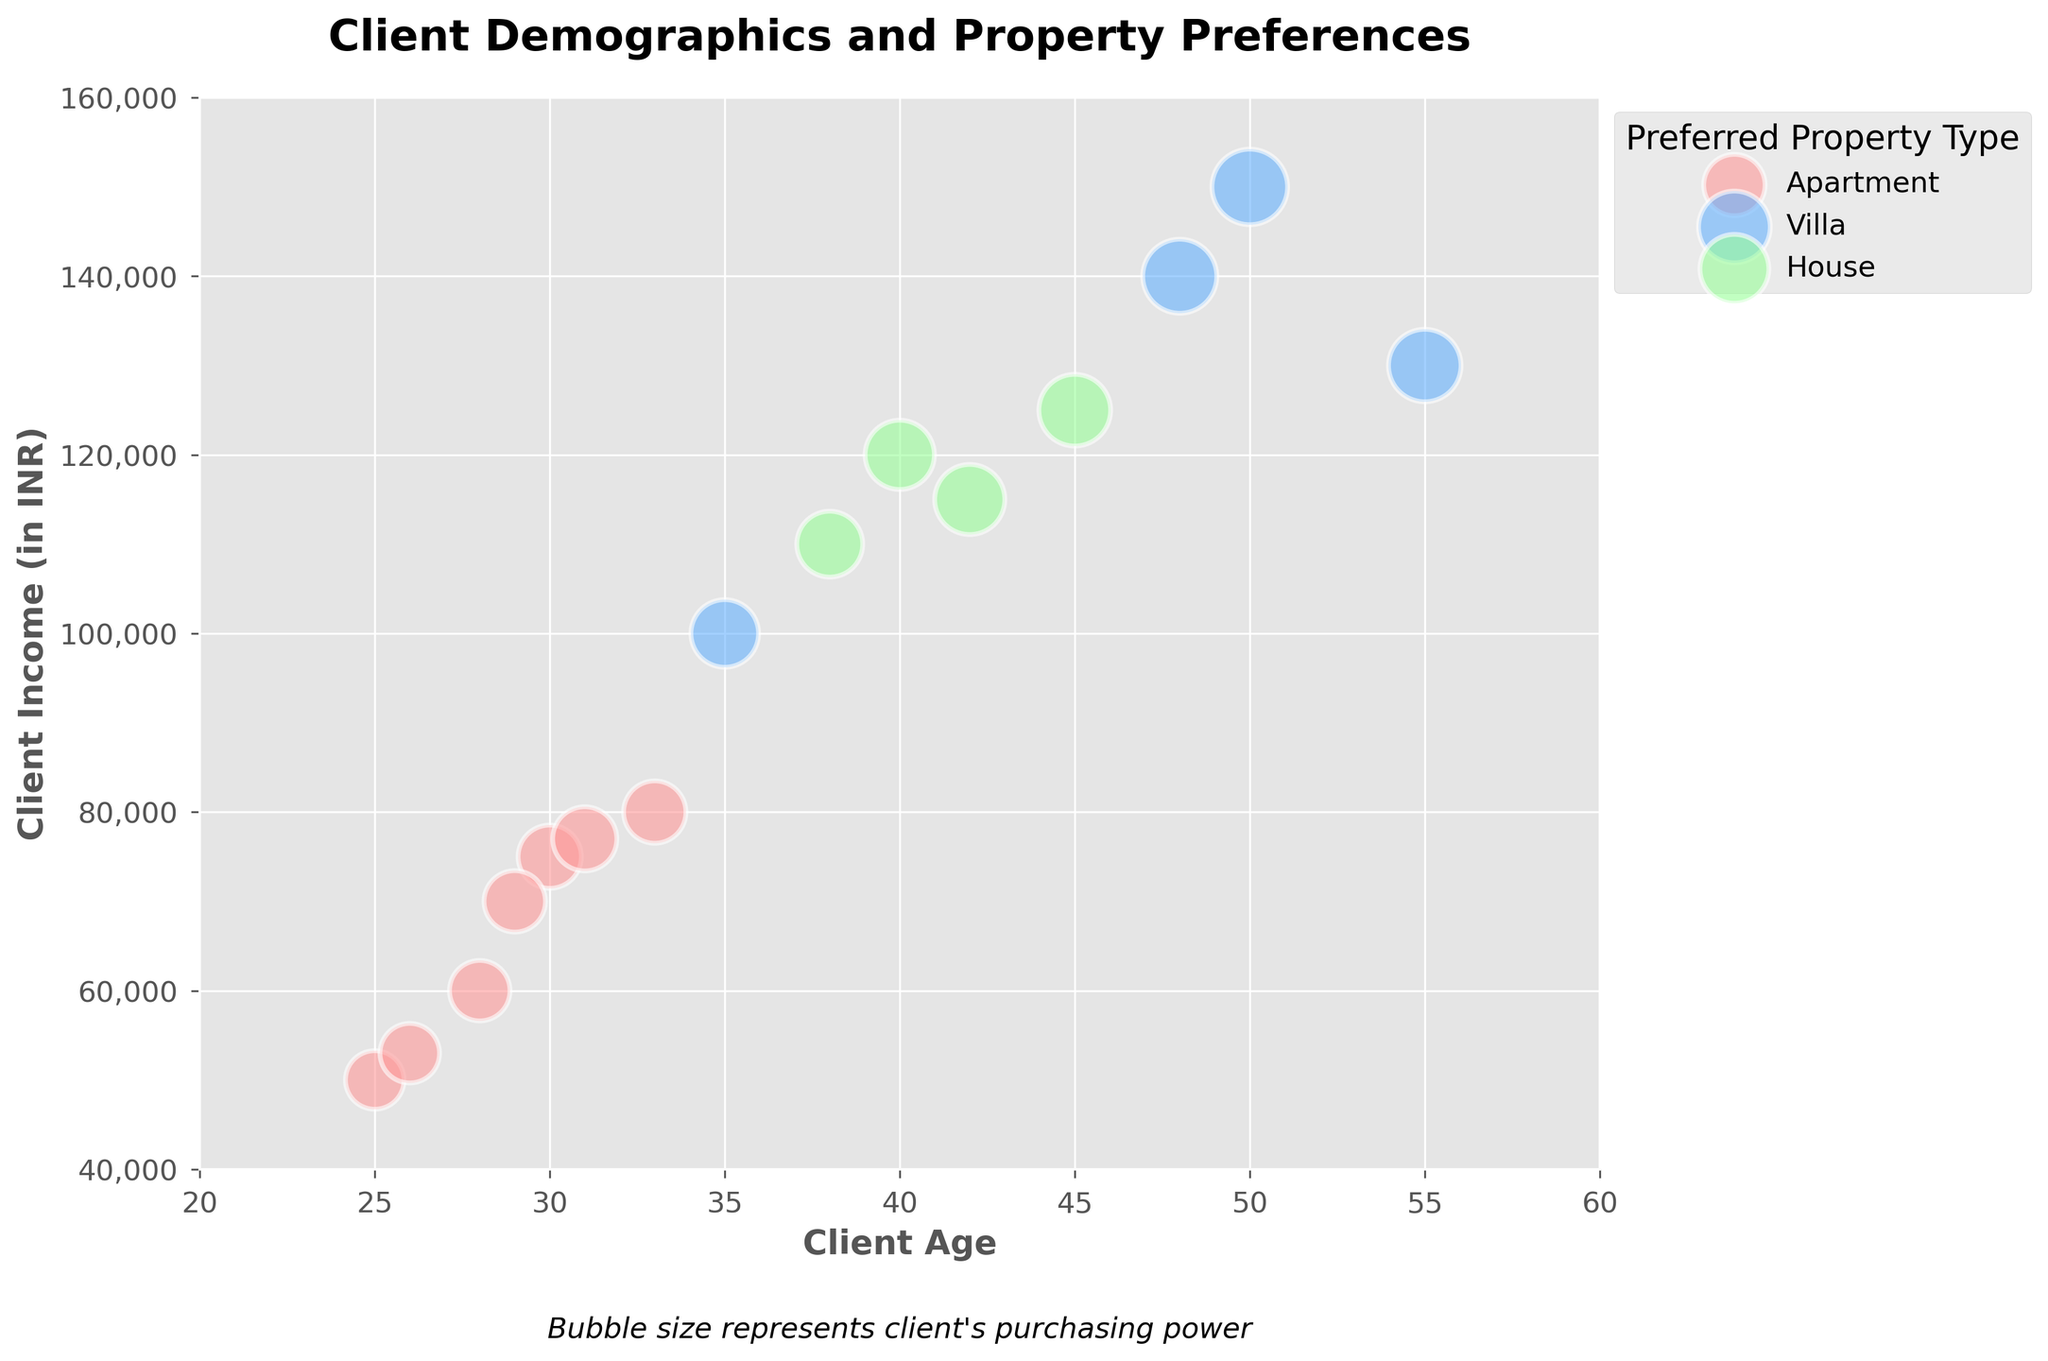What is the title of the figure? The title is displayed at the top of the figure in a bold font.
Answer: Client Demographics and Property Preferences What is the client’s age for the data point with the largest bubble? The largest bubble represents the client with the highest purchasing power, which can be inferred by comparing bubble sizes. This point corresponds to the age of 50.
Answer: 50 How many clients prefer apartments? Count the number of bubbles colored in pink, which represent apartments.
Answer: 7 Which property type has the highest client age? Observe the highest age value on the x-axis and check the bubble's color, which corresponds to Villa.
Answer: Villa What is the highest income among clients that prefer houses? Check the y-axis values for the green bubbles which represent houses. The highest income value is 120,000 INR.
Answer: 120,000 INR What is the average income of clients aged 30 and above who prefer villas? Identify the bubbles with ages 30 and above, select the blue ones (villas), and calculate the average income: (100000 + 150000 + 130000 + 140000) / 4 = 130,000 INR.
Answer: 130,000 INR Which property type has the densest clustering of bubbles? Observe the spatial distribution of the bubbles on the figure. The pink bubbles, representing apartments, are more closely packed.
Answer: Apartment What is the range of client ages for those who prefer houses? Identify the ages represented by green bubbles on the x-axis and determine the range: maximum age (45) - minimum age (38).
Answer: 38-45 Among clients with an income of 100,000 INR, how many prefer villas? Identify the blue bubbles along the y-axis at 100,000 INR. There is one such bubble.
Answer: 1 Which age group has the highest purchasing power and which property type do they prefer? Compare bubble sizes across age groups. The largest bubble size is at age 50, corresponding to a Villa.
Answer: Age 50, Villa 